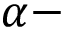<formula> <loc_0><loc_0><loc_500><loc_500>\alpha -</formula> 